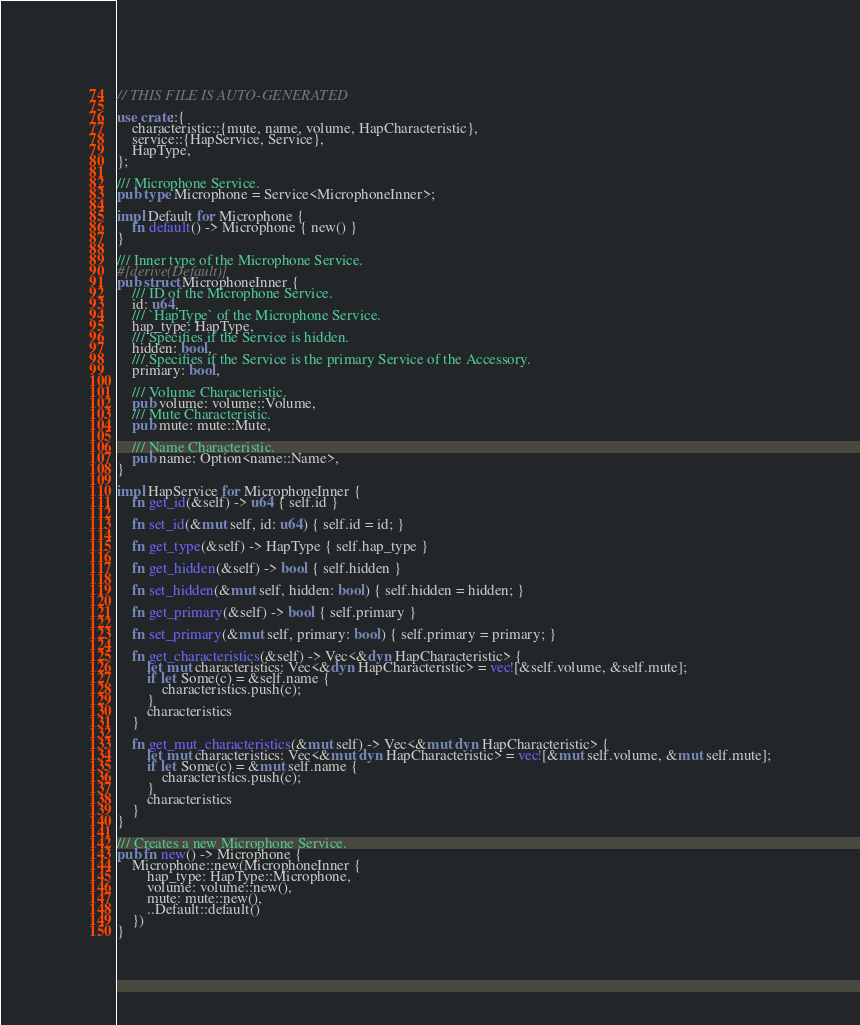<code> <loc_0><loc_0><loc_500><loc_500><_Rust_>// THIS FILE IS AUTO-GENERATED

use crate::{
    characteristic::{mute, name, volume, HapCharacteristic},
    service::{HapService, Service},
    HapType,
};

/// Microphone Service.
pub type Microphone = Service<MicrophoneInner>;

impl Default for Microphone {
    fn default() -> Microphone { new() }
}

/// Inner type of the Microphone Service.
#[derive(Default)]
pub struct MicrophoneInner {
    /// ID of the Microphone Service.
    id: u64,
    /// `HapType` of the Microphone Service.
    hap_type: HapType,
    /// Specifies if the Service is hidden.
    hidden: bool,
    /// Specifies if the Service is the primary Service of the Accessory.
    primary: bool,

    /// Volume Characteristic.
    pub volume: volume::Volume,
    /// Mute Characteristic.
    pub mute: mute::Mute,

    /// Name Characteristic.
    pub name: Option<name::Name>,
}

impl HapService for MicrophoneInner {
    fn get_id(&self) -> u64 { self.id }

    fn set_id(&mut self, id: u64) { self.id = id; }

    fn get_type(&self) -> HapType { self.hap_type }

    fn get_hidden(&self) -> bool { self.hidden }

    fn set_hidden(&mut self, hidden: bool) { self.hidden = hidden; }

    fn get_primary(&self) -> bool { self.primary }

    fn set_primary(&mut self, primary: bool) { self.primary = primary; }

    fn get_characteristics(&self) -> Vec<&dyn HapCharacteristic> {
        let mut characteristics: Vec<&dyn HapCharacteristic> = vec![&self.volume, &self.mute];
        if let Some(c) = &self.name {
            characteristics.push(c);
        }
        characteristics
    }

    fn get_mut_characteristics(&mut self) -> Vec<&mut dyn HapCharacteristic> {
        let mut characteristics: Vec<&mut dyn HapCharacteristic> = vec![&mut self.volume, &mut self.mute];
        if let Some(c) = &mut self.name {
            characteristics.push(c);
        }
        characteristics
    }
}

/// Creates a new Microphone Service.
pub fn new() -> Microphone {
    Microphone::new(MicrophoneInner {
        hap_type: HapType::Microphone,
        volume: volume::new(),
        mute: mute::new(),
        ..Default::default()
    })
}
</code> 